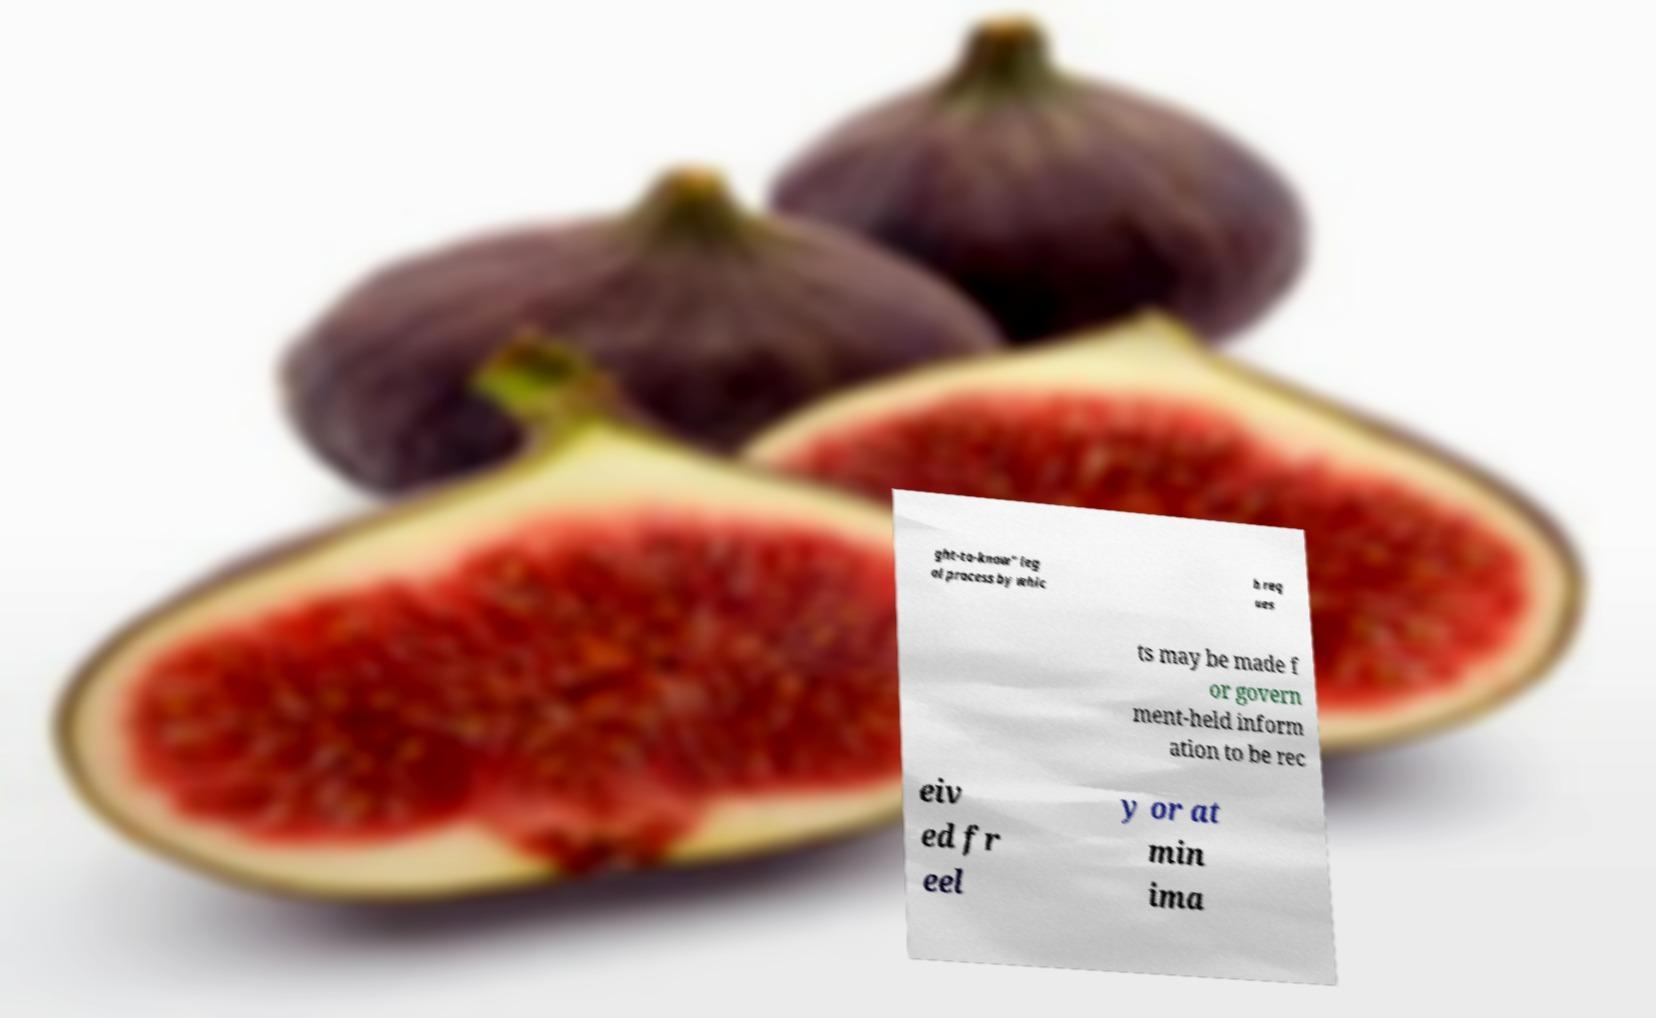I need the written content from this picture converted into text. Can you do that? ght-to-know" leg al process by whic h req ues ts may be made f or govern ment-held inform ation to be rec eiv ed fr eel y or at min ima 